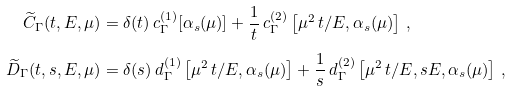<formula> <loc_0><loc_0><loc_500><loc_500>\widetilde { C } _ { \Gamma } ( t , E , \mu ) & = \delta ( t ) \, c _ { \Gamma } ^ { ( 1 ) } [ \alpha _ { s } ( \mu ) ] + \frac { 1 } { t } \, c _ { \Gamma } ^ { ( 2 ) } \left [ \mu ^ { 2 } \, t / E , \alpha _ { s } ( \mu ) \right ] \, , \\ \widetilde { D } _ { \Gamma } ( t , s , E , \mu ) & = \delta ( s ) \, d _ { \Gamma } ^ { ( 1 ) } \left [ \mu ^ { 2 } \, t / E , \alpha _ { s } ( \mu ) \right ] + \frac { 1 } { s } \, d _ { \Gamma } ^ { ( 2 ) } \left [ \mu ^ { 2 } \, t / E , s E , \alpha _ { s } ( \mu ) \right ] \, ,</formula> 